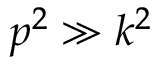<formula> <loc_0><loc_0><loc_500><loc_500>p ^ { 2 } \gg k ^ { 2 }</formula> 